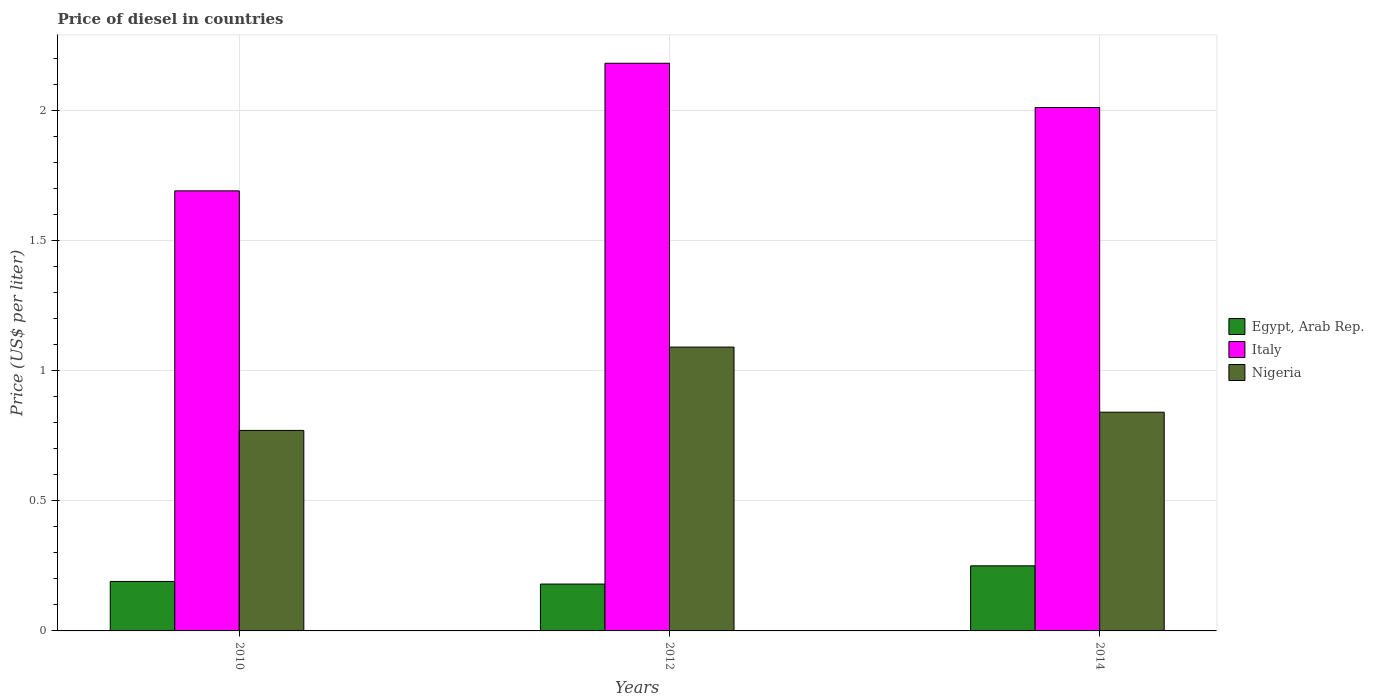Are the number of bars on each tick of the X-axis equal?
Your answer should be very brief. Yes. How many bars are there on the 1st tick from the left?
Provide a succinct answer. 3. How many bars are there on the 3rd tick from the right?
Your answer should be very brief. 3. What is the price of diesel in Nigeria in 2014?
Provide a succinct answer. 0.84. Across all years, what is the maximum price of diesel in Italy?
Keep it short and to the point. 2.18. Across all years, what is the minimum price of diesel in Italy?
Provide a short and direct response. 1.69. What is the total price of diesel in Nigeria in the graph?
Ensure brevity in your answer.  2.7. What is the difference between the price of diesel in Nigeria in 2010 and that in 2014?
Your response must be concise. -0.07. What is the difference between the price of diesel in Nigeria in 2014 and the price of diesel in Egypt, Arab Rep. in 2012?
Offer a very short reply. 0.66. In the year 2014, what is the difference between the price of diesel in Italy and price of diesel in Nigeria?
Provide a short and direct response. 1.17. What is the ratio of the price of diesel in Italy in 2010 to that in 2012?
Provide a succinct answer. 0.78. What is the difference between the highest and the second highest price of diesel in Egypt, Arab Rep.?
Your response must be concise. 0.06. What is the difference between the highest and the lowest price of diesel in Nigeria?
Your response must be concise. 0.32. What does the 3rd bar from the left in 2010 represents?
Ensure brevity in your answer.  Nigeria. Is it the case that in every year, the sum of the price of diesel in Egypt, Arab Rep. and price of diesel in Nigeria is greater than the price of diesel in Italy?
Make the answer very short. No. How many bars are there?
Provide a short and direct response. 9. Are all the bars in the graph horizontal?
Make the answer very short. No. How many years are there in the graph?
Make the answer very short. 3. Does the graph contain any zero values?
Offer a terse response. No. Does the graph contain grids?
Your response must be concise. Yes. What is the title of the graph?
Offer a terse response. Price of diesel in countries. Does "St. Vincent and the Grenadines" appear as one of the legend labels in the graph?
Give a very brief answer. No. What is the label or title of the X-axis?
Offer a terse response. Years. What is the label or title of the Y-axis?
Ensure brevity in your answer.  Price (US$ per liter). What is the Price (US$ per liter) in Egypt, Arab Rep. in 2010?
Offer a very short reply. 0.19. What is the Price (US$ per liter) in Italy in 2010?
Your answer should be very brief. 1.69. What is the Price (US$ per liter) in Nigeria in 2010?
Provide a short and direct response. 0.77. What is the Price (US$ per liter) in Egypt, Arab Rep. in 2012?
Your answer should be very brief. 0.18. What is the Price (US$ per liter) in Italy in 2012?
Give a very brief answer. 2.18. What is the Price (US$ per liter) of Nigeria in 2012?
Ensure brevity in your answer.  1.09. What is the Price (US$ per liter) of Italy in 2014?
Keep it short and to the point. 2.01. What is the Price (US$ per liter) of Nigeria in 2014?
Offer a terse response. 0.84. Across all years, what is the maximum Price (US$ per liter) of Egypt, Arab Rep.?
Your answer should be very brief. 0.25. Across all years, what is the maximum Price (US$ per liter) of Italy?
Give a very brief answer. 2.18. Across all years, what is the maximum Price (US$ per liter) in Nigeria?
Offer a terse response. 1.09. Across all years, what is the minimum Price (US$ per liter) of Egypt, Arab Rep.?
Offer a terse response. 0.18. Across all years, what is the minimum Price (US$ per liter) of Italy?
Your answer should be very brief. 1.69. Across all years, what is the minimum Price (US$ per liter) in Nigeria?
Provide a succinct answer. 0.77. What is the total Price (US$ per liter) in Egypt, Arab Rep. in the graph?
Provide a short and direct response. 0.62. What is the total Price (US$ per liter) in Italy in the graph?
Make the answer very short. 5.88. What is the difference between the Price (US$ per liter) in Italy in 2010 and that in 2012?
Your answer should be compact. -0.49. What is the difference between the Price (US$ per liter) in Nigeria in 2010 and that in 2012?
Provide a short and direct response. -0.32. What is the difference between the Price (US$ per liter) in Egypt, Arab Rep. in 2010 and that in 2014?
Keep it short and to the point. -0.06. What is the difference between the Price (US$ per liter) of Italy in 2010 and that in 2014?
Your answer should be compact. -0.32. What is the difference between the Price (US$ per liter) of Nigeria in 2010 and that in 2014?
Make the answer very short. -0.07. What is the difference between the Price (US$ per liter) of Egypt, Arab Rep. in 2012 and that in 2014?
Provide a succinct answer. -0.07. What is the difference between the Price (US$ per liter) of Italy in 2012 and that in 2014?
Provide a short and direct response. 0.17. What is the difference between the Price (US$ per liter) in Egypt, Arab Rep. in 2010 and the Price (US$ per liter) in Italy in 2012?
Provide a succinct answer. -1.99. What is the difference between the Price (US$ per liter) of Egypt, Arab Rep. in 2010 and the Price (US$ per liter) of Italy in 2014?
Ensure brevity in your answer.  -1.82. What is the difference between the Price (US$ per liter) of Egypt, Arab Rep. in 2010 and the Price (US$ per liter) of Nigeria in 2014?
Your answer should be very brief. -0.65. What is the difference between the Price (US$ per liter) of Egypt, Arab Rep. in 2012 and the Price (US$ per liter) of Italy in 2014?
Your response must be concise. -1.83. What is the difference between the Price (US$ per liter) in Egypt, Arab Rep. in 2012 and the Price (US$ per liter) in Nigeria in 2014?
Make the answer very short. -0.66. What is the difference between the Price (US$ per liter) of Italy in 2012 and the Price (US$ per liter) of Nigeria in 2014?
Make the answer very short. 1.34. What is the average Price (US$ per liter) in Egypt, Arab Rep. per year?
Your response must be concise. 0.21. What is the average Price (US$ per liter) of Italy per year?
Ensure brevity in your answer.  1.96. What is the average Price (US$ per liter) of Nigeria per year?
Give a very brief answer. 0.9. In the year 2010, what is the difference between the Price (US$ per liter) of Egypt, Arab Rep. and Price (US$ per liter) of Nigeria?
Keep it short and to the point. -0.58. In the year 2012, what is the difference between the Price (US$ per liter) in Egypt, Arab Rep. and Price (US$ per liter) in Nigeria?
Provide a short and direct response. -0.91. In the year 2012, what is the difference between the Price (US$ per liter) of Italy and Price (US$ per liter) of Nigeria?
Your answer should be compact. 1.09. In the year 2014, what is the difference between the Price (US$ per liter) of Egypt, Arab Rep. and Price (US$ per liter) of Italy?
Provide a succinct answer. -1.76. In the year 2014, what is the difference between the Price (US$ per liter) of Egypt, Arab Rep. and Price (US$ per liter) of Nigeria?
Your response must be concise. -0.59. In the year 2014, what is the difference between the Price (US$ per liter) in Italy and Price (US$ per liter) in Nigeria?
Provide a succinct answer. 1.17. What is the ratio of the Price (US$ per liter) in Egypt, Arab Rep. in 2010 to that in 2012?
Provide a succinct answer. 1.06. What is the ratio of the Price (US$ per liter) in Italy in 2010 to that in 2012?
Ensure brevity in your answer.  0.78. What is the ratio of the Price (US$ per liter) in Nigeria in 2010 to that in 2012?
Your answer should be very brief. 0.71. What is the ratio of the Price (US$ per liter) of Egypt, Arab Rep. in 2010 to that in 2014?
Your answer should be very brief. 0.76. What is the ratio of the Price (US$ per liter) of Italy in 2010 to that in 2014?
Offer a terse response. 0.84. What is the ratio of the Price (US$ per liter) in Egypt, Arab Rep. in 2012 to that in 2014?
Provide a succinct answer. 0.72. What is the ratio of the Price (US$ per liter) of Italy in 2012 to that in 2014?
Keep it short and to the point. 1.08. What is the ratio of the Price (US$ per liter) of Nigeria in 2012 to that in 2014?
Offer a terse response. 1.3. What is the difference between the highest and the second highest Price (US$ per liter) in Italy?
Give a very brief answer. 0.17. What is the difference between the highest and the lowest Price (US$ per liter) in Egypt, Arab Rep.?
Offer a terse response. 0.07. What is the difference between the highest and the lowest Price (US$ per liter) of Italy?
Provide a succinct answer. 0.49. What is the difference between the highest and the lowest Price (US$ per liter) of Nigeria?
Offer a terse response. 0.32. 